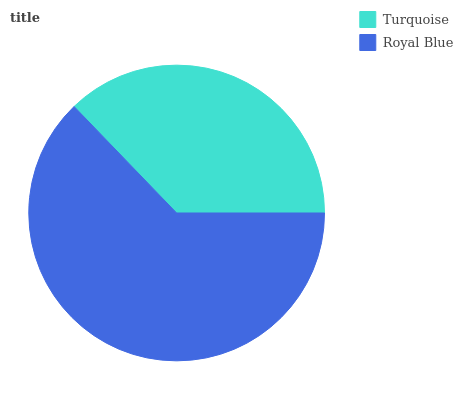Is Turquoise the minimum?
Answer yes or no. Yes. Is Royal Blue the maximum?
Answer yes or no. Yes. Is Royal Blue the minimum?
Answer yes or no. No. Is Royal Blue greater than Turquoise?
Answer yes or no. Yes. Is Turquoise less than Royal Blue?
Answer yes or no. Yes. Is Turquoise greater than Royal Blue?
Answer yes or no. No. Is Royal Blue less than Turquoise?
Answer yes or no. No. Is Royal Blue the high median?
Answer yes or no. Yes. Is Turquoise the low median?
Answer yes or no. Yes. Is Turquoise the high median?
Answer yes or no. No. Is Royal Blue the low median?
Answer yes or no. No. 